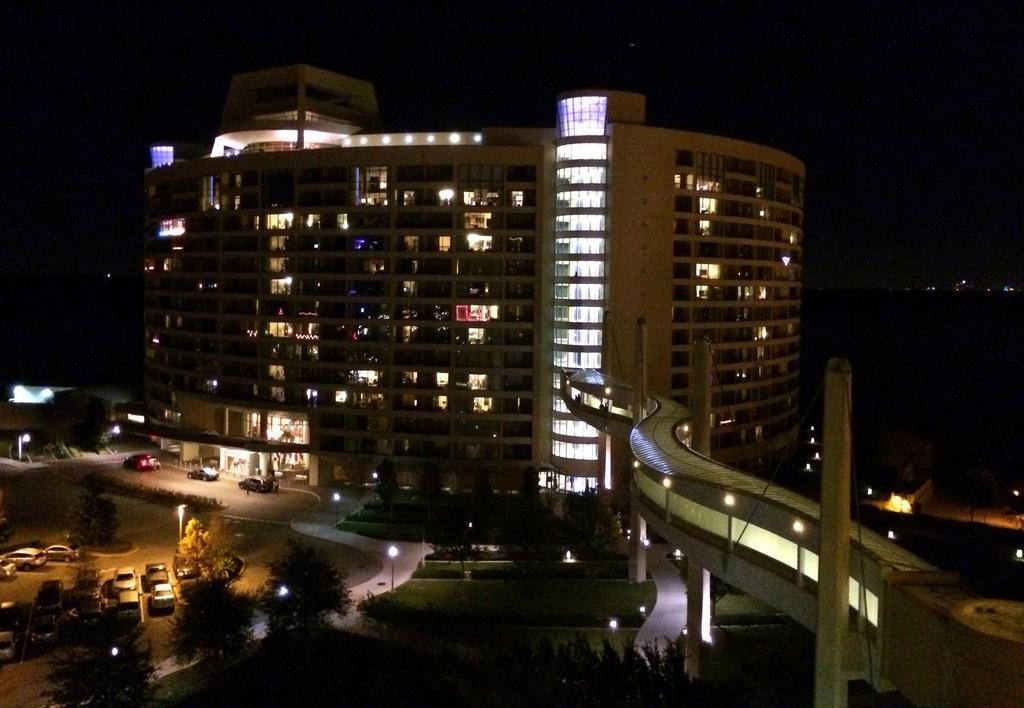Could you give a brief overview of what you see in this image? In this picture I can see the buildings. In the bottom left corner I can see many cars which are parked in the parking. Beside that I can see the trees, plants and grass. At the top I can see the sky and clouds. On the right I can see the bridge, window, poles and other objects. 